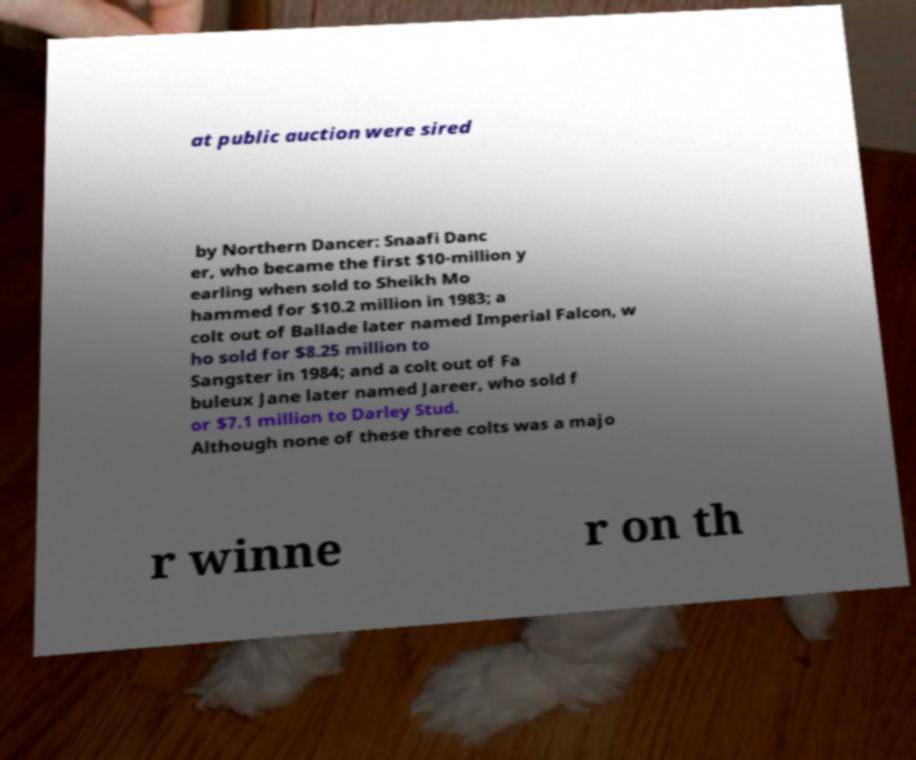Could you assist in decoding the text presented in this image and type it out clearly? at public auction were sired by Northern Dancer: Snaafi Danc er, who became the first $10-million y earling when sold to Sheikh Mo hammed for $10.2 million in 1983; a colt out of Ballade later named Imperial Falcon, w ho sold for $8.25 million to Sangster in 1984; and a colt out of Fa buleux Jane later named Jareer, who sold f or $7.1 million to Darley Stud. Although none of these three colts was a majo r winne r on th 